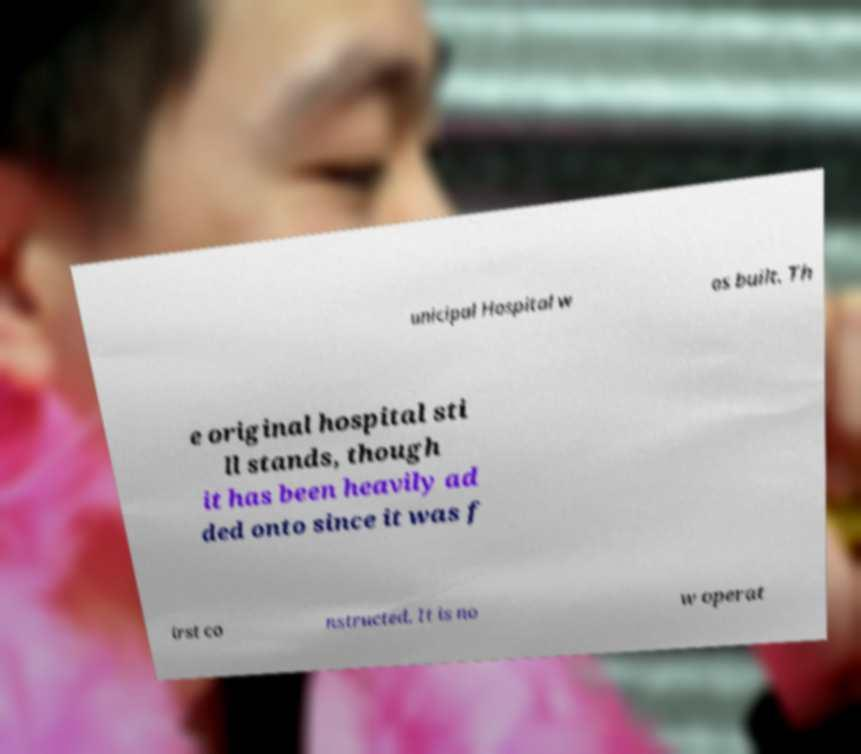There's text embedded in this image that I need extracted. Can you transcribe it verbatim? unicipal Hospital w as built. Th e original hospital sti ll stands, though it has been heavily ad ded onto since it was f irst co nstructed. It is no w operat 